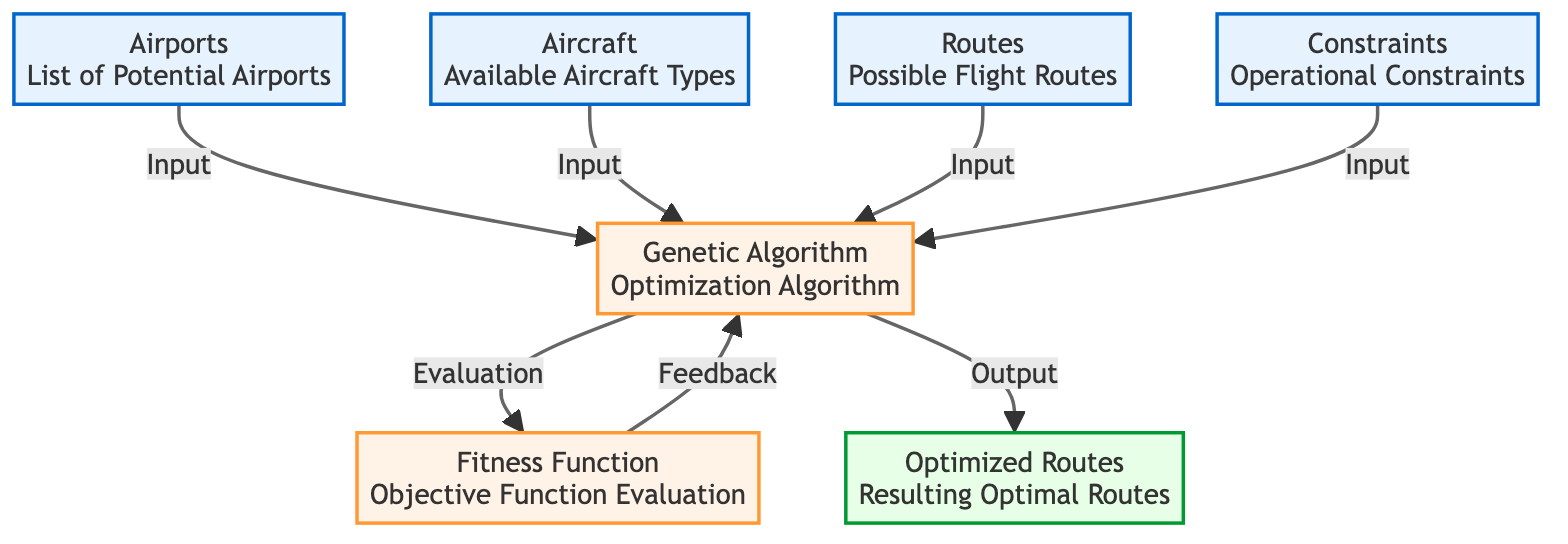What are the inputs to the Genetic Algorithm? The inputs to the Genetic Algorithm include airports, aircraft, routes, and constraints, as shown by the arrows leading to the GA node.
Answer: airports, aircraft, routes, constraints How many process nodes are in the diagram? The process nodes in the diagram are the Genetic Algorithm and the Fitness Function, making a total of two process nodes.
Answer: 2 What output is generated from the Genetic Algorithm? The output generated from the Genetic Algorithm is the optimized routes, as indicated by the arrow pointing from the GA to the optimized routes node.
Answer: Optimized Routes Which node evaluates the objective function? The node that evaluates the objective function is the Fitness Function, which is connected to the Genetic Algorithm for feedback.
Answer: Fitness Function What is the relationship between the Fitness Function and the Genetic Algorithm? The Fitness Function provides feedback to the Genetic Algorithm, meaning that the output from the fitness function affects the GA's optimization process.
Answer: Feedback What is the main role of the Airports node in this diagram? The main role of the Airports node is to provide a list of potential airports, which serves as an input to the Genetic Algorithm for route optimization.
Answer: List of Potential Airports If there are operational constraints, which node would they connect to? Operational constraints connect to the Genetic Algorithm node, as they are one of its inputs.
Answer: Genetic Algorithm What follows the Fitness Function in the optimization process? The process that follows the Fitness Function is the Genetic Algorithm, which takes the evaluation feedback to optimize its routes.
Answer: Genetic Algorithm 